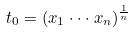<formula> <loc_0><loc_0><loc_500><loc_500>t _ { 0 } = ( x _ { 1 } \cdot \cdot \cdot x _ { n } ) ^ { \frac { 1 } { n } }</formula> 